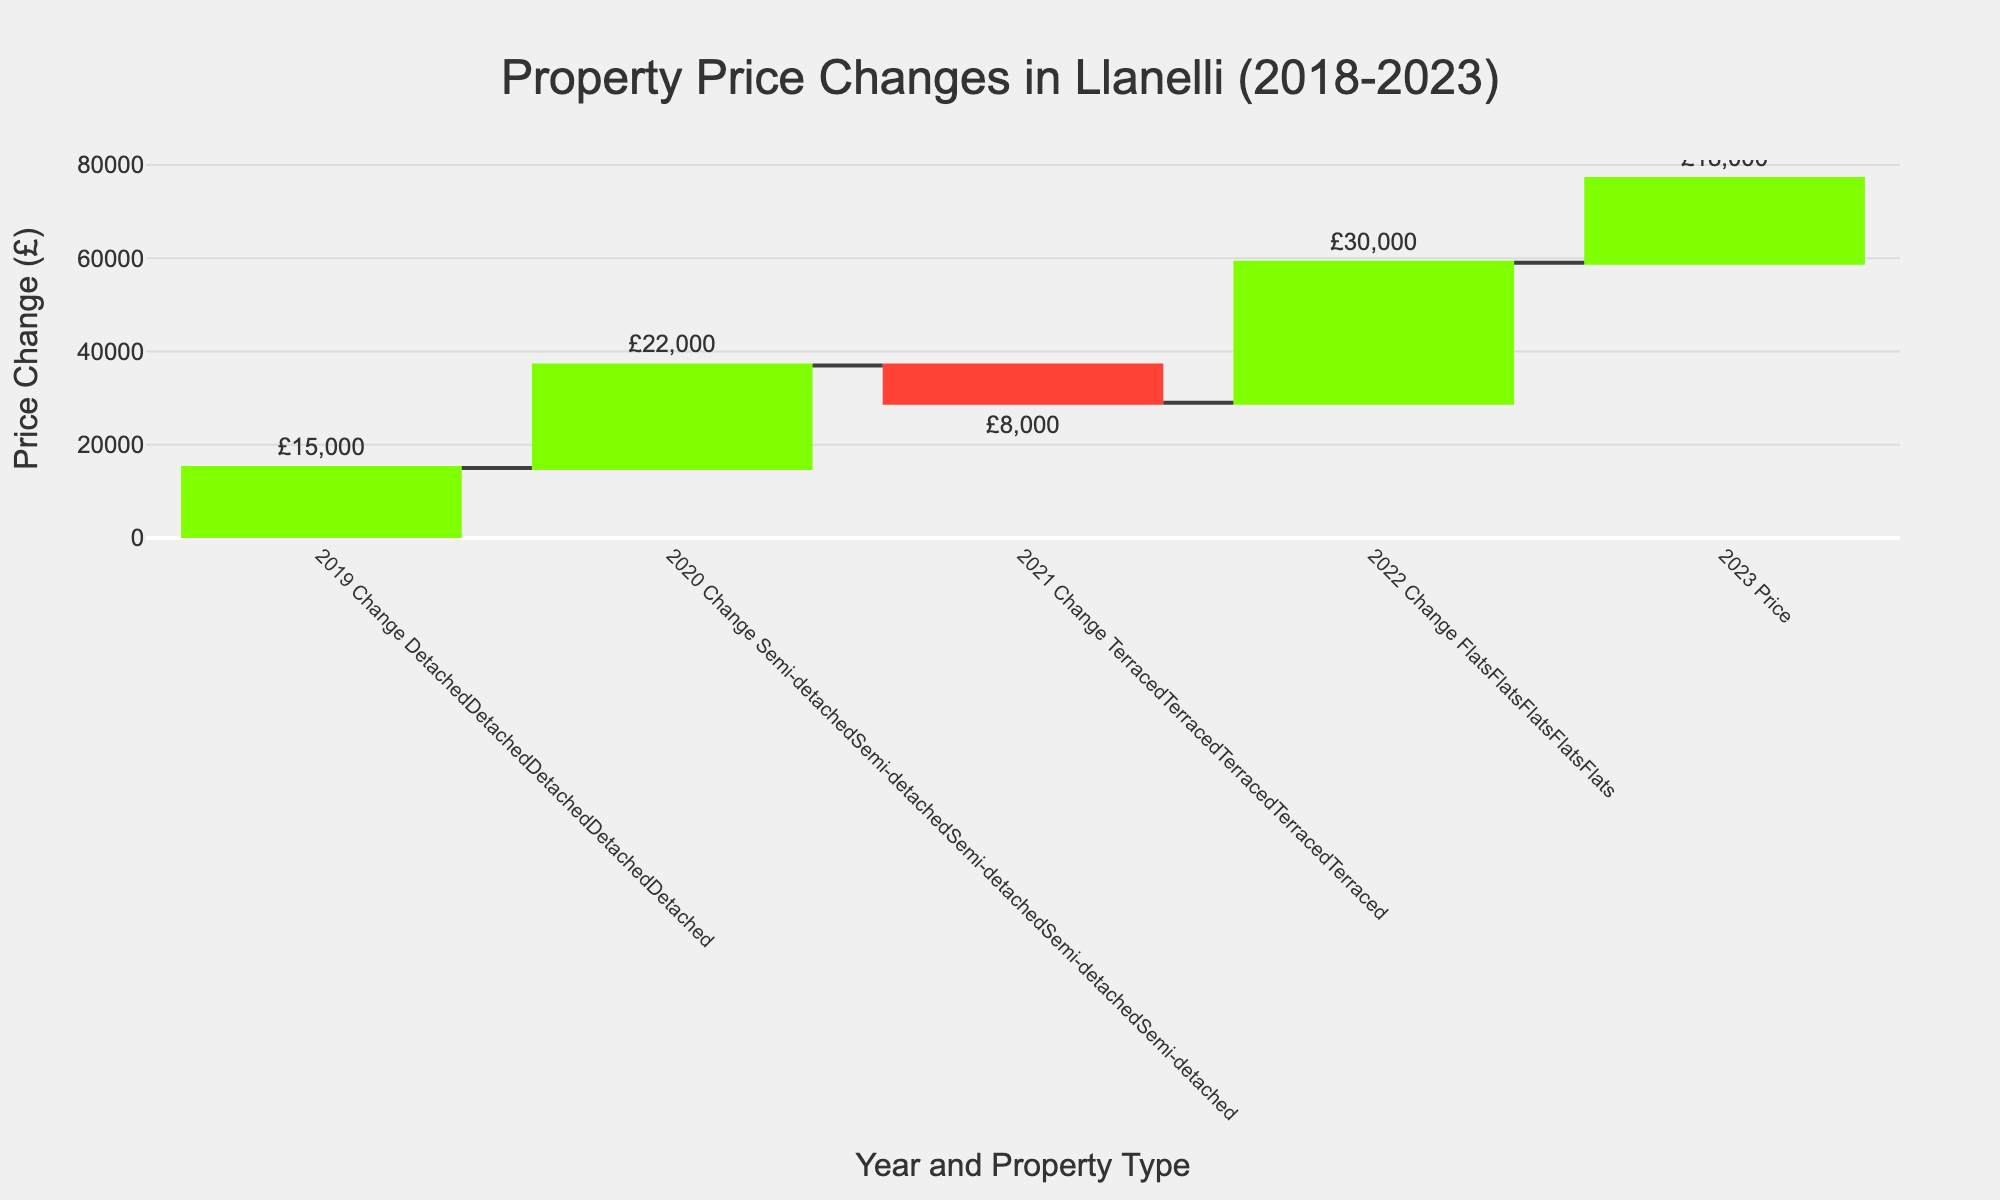What's the title of the chart? The title of the chart is usually shown at the top center of the figure. It is set to clearly describe what the chart is about.
Answer: Property Price Changes in Llanelli (2018-2023) Which property type had the highest price change in 2021? First, look at the year 2021 on the x-axis, and then identify the property type with the highest bar, which indicates the greatest change in price.
Answer: Detached What was the final price of terraced houses in 2023? To find this, look for the total value (2023 Price) for the Terraced property type. The total price is the sum of the initial price in 2018 and all the changes from 2019 to 2023.
Answer: £181,000 How much did the price of flats increase from 2018 to 2020? Check the price changes for flats in 2019 and 2020 and sum them up. The specific values are the bars for Flats under the years 2019 and 2020.
Answer: £11,000 Which property type experienced a price decrease in 2021? Locate the year 2021 on the x-axis, and look for a red bar indicating a price decrease. Identify the corresponding property type.
Answer: Detached, Semi-detached, Terraced, Flats Which property type had the smallest cumulative price change over the period 2019-2023? To find this, you must sum the yearly changes (including negative ones) for each property type and compare them. The smallest sum denotes the property type with the smallest change.
Answer: Flats How does the price change of semi-detached houses in 2023 compare to detached houses? Look at the 2023 bars for both semi-detached and detached houses. Compare their heights or the values indicated above the bars.
Answer: Semi-detached had a smaller increase What was the price of semi-detached houses in 2022 before the 2023 change was added? Sum the original price in 2018 and all changes up to and including 2022. Exclude the change for 2023.
Answer: £217,000 